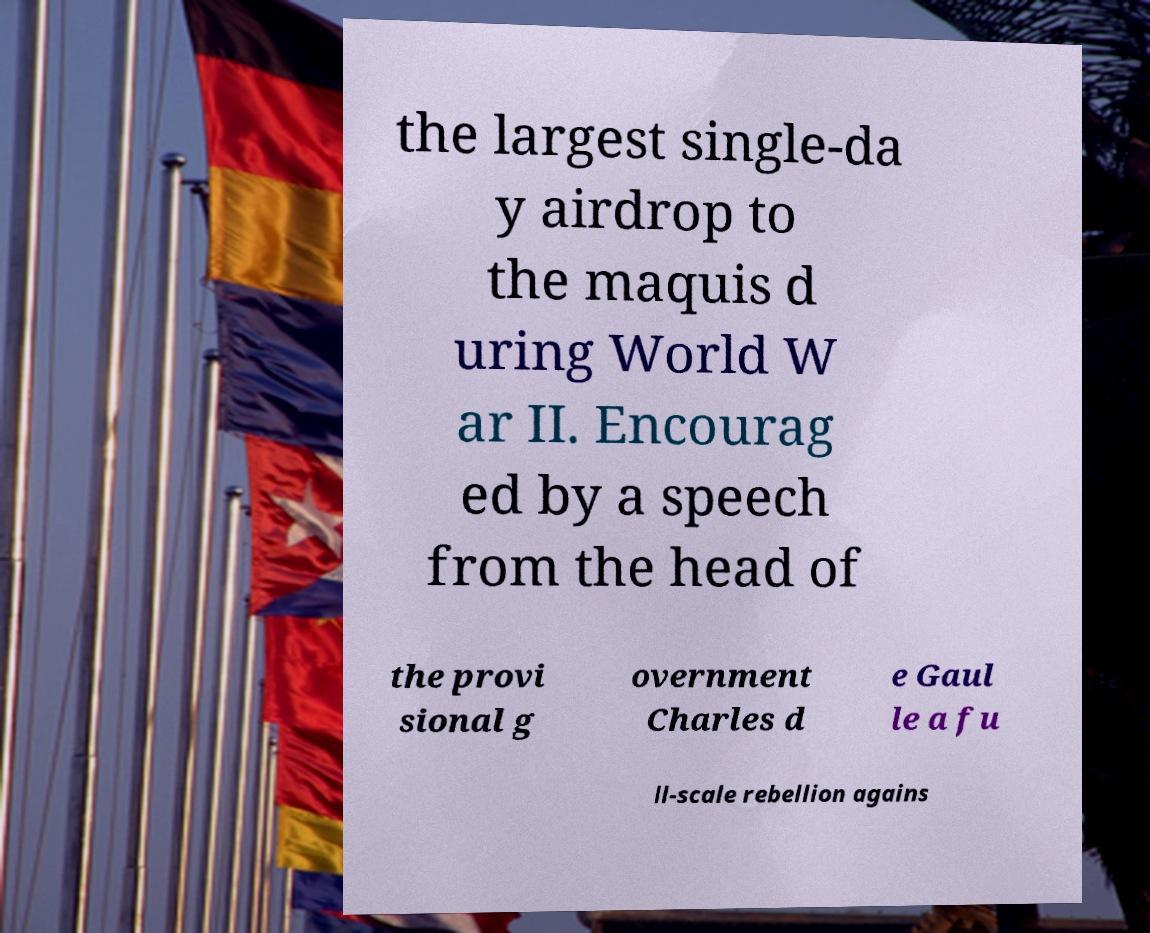Can you accurately transcribe the text from the provided image for me? the largest single-da y airdrop to the maquis d uring World W ar II. Encourag ed by a speech from the head of the provi sional g overnment Charles d e Gaul le a fu ll-scale rebellion agains 